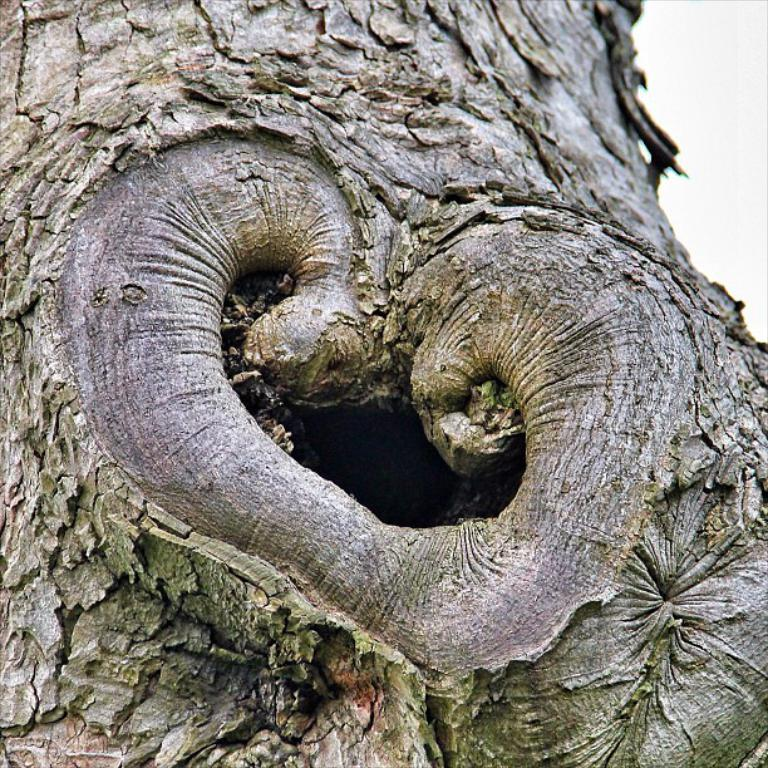What is attached to the tree in the image? There is a trunk on the bark of a tree in the image. What type of picture is hanging on the wall in the image? There is no wall or picture present in the image; it only features a trunk on the bark of a tree. 